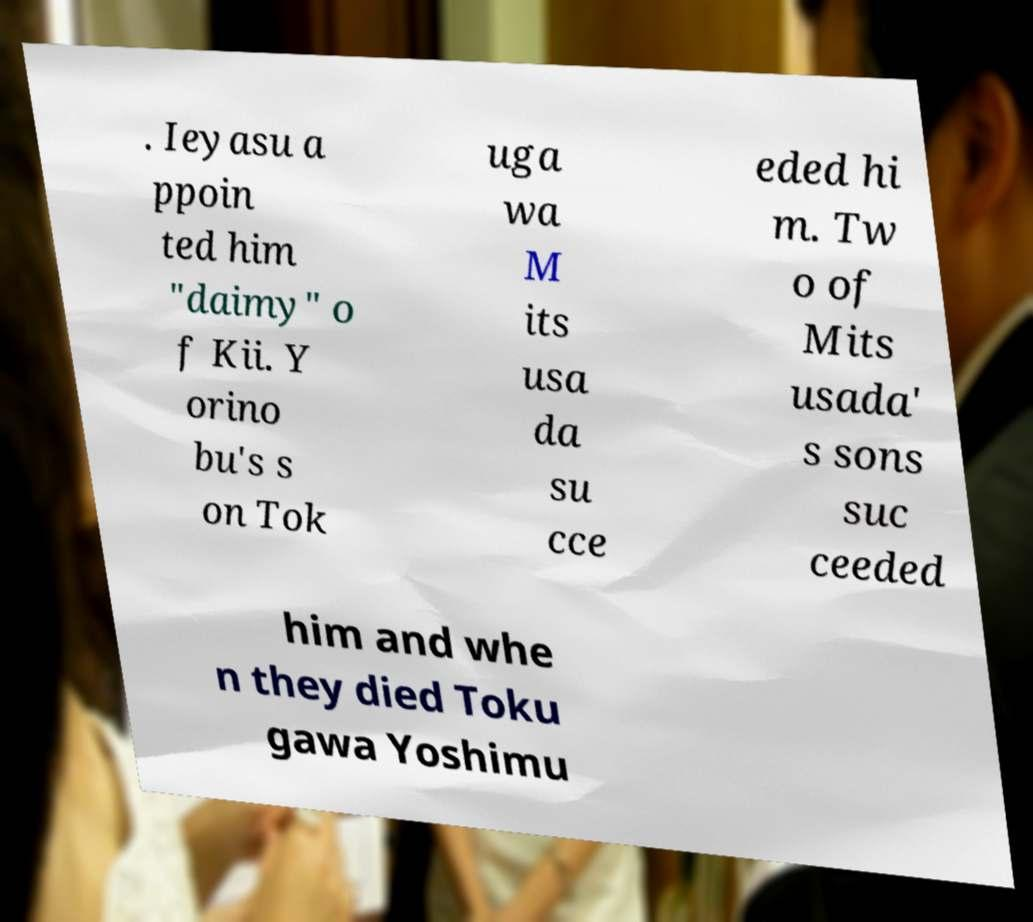For documentation purposes, I need the text within this image transcribed. Could you provide that? . Ieyasu a ppoin ted him "daimy" o f Kii. Y orino bu's s on Tok uga wa M its usa da su cce eded hi m. Tw o of Mits usada' s sons suc ceeded him and whe n they died Toku gawa Yoshimu 